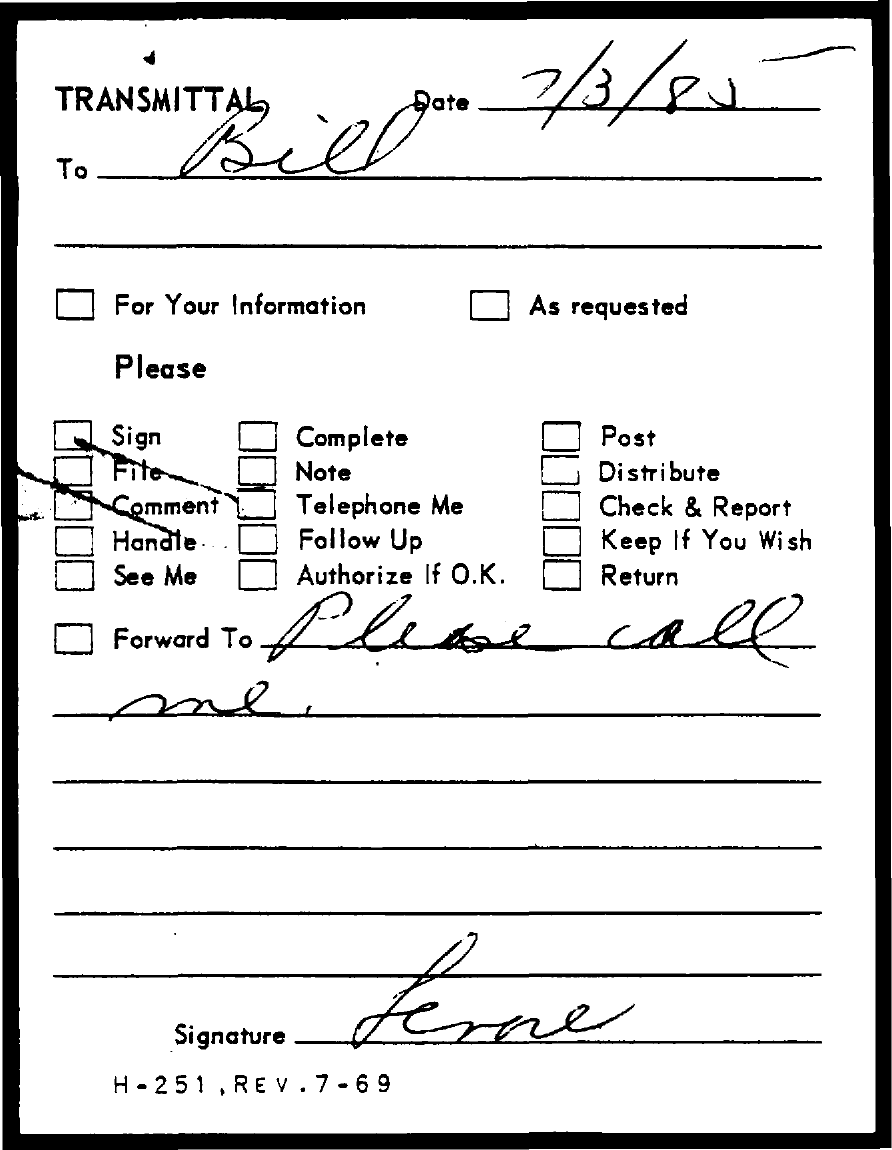List a handful of essential elements in this visual. The transmittal is addressed to Bill. 